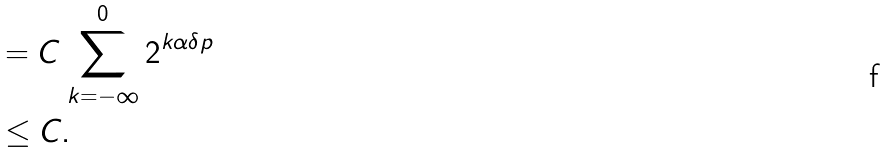<formula> <loc_0><loc_0><loc_500><loc_500>& = C \sum _ { k = - \infty } ^ { 0 } 2 ^ { k \alpha \delta p } \\ & \leq C .</formula> 